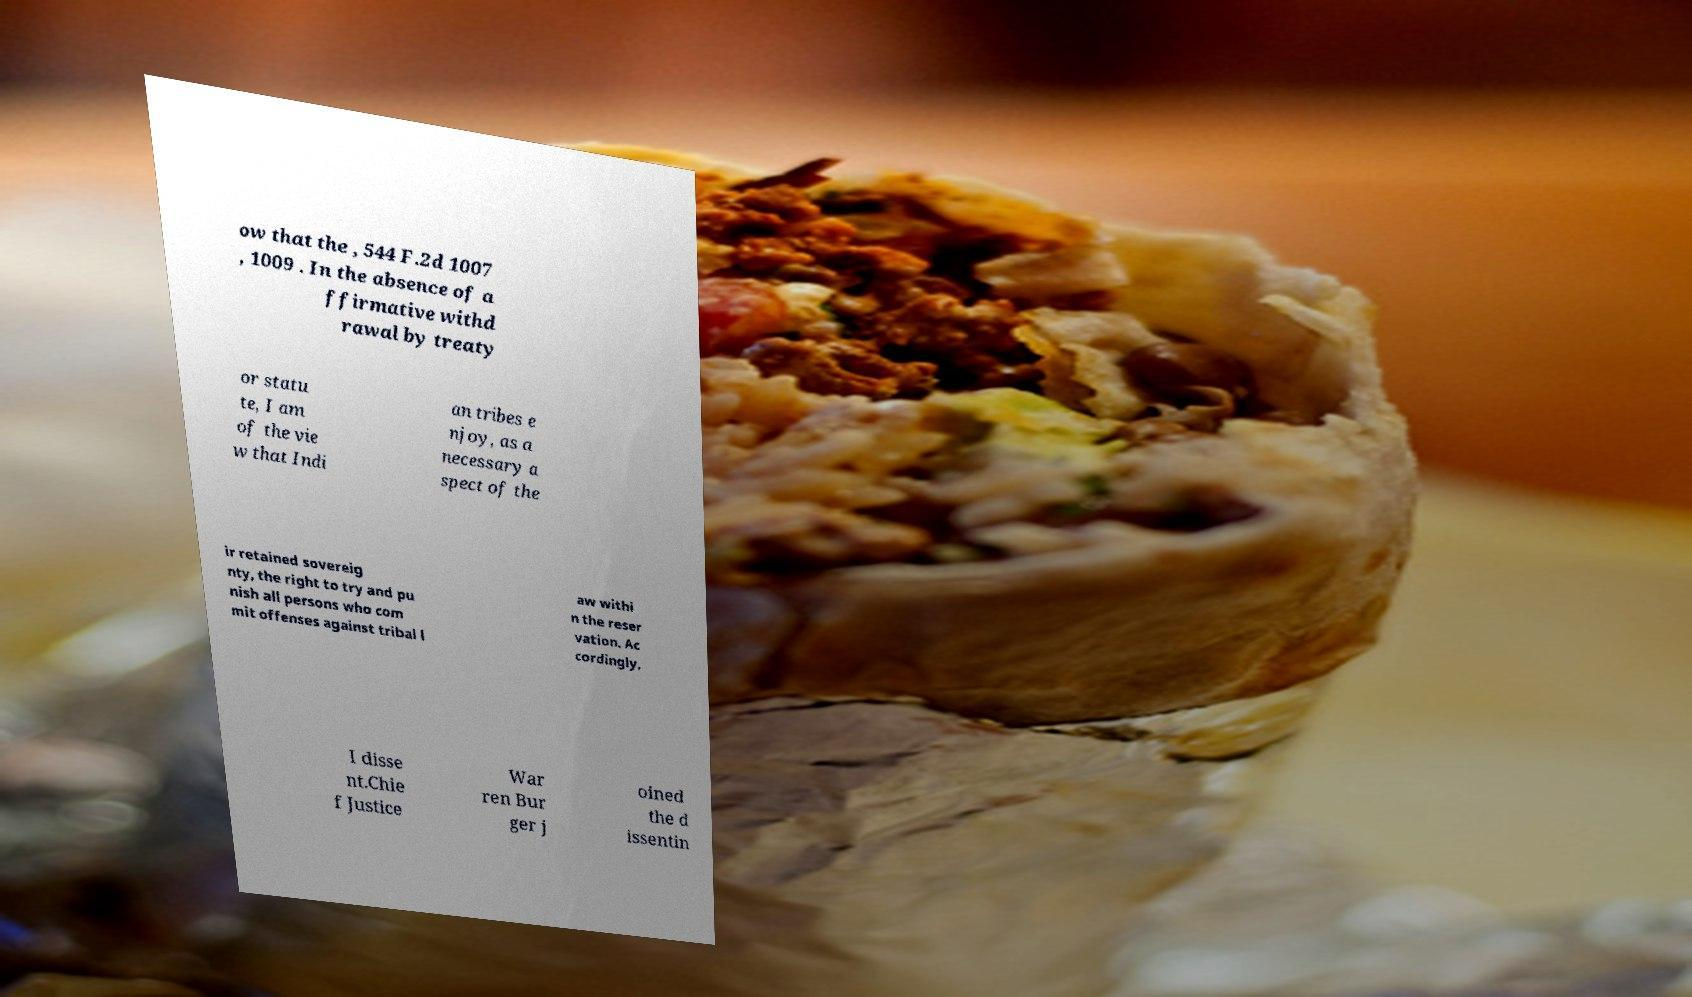I need the written content from this picture converted into text. Can you do that? ow that the , 544 F.2d 1007 , 1009 . In the absence of a ffirmative withd rawal by treaty or statu te, I am of the vie w that Indi an tribes e njoy, as a necessary a spect of the ir retained sovereig nty, the right to try and pu nish all persons who com mit offenses against tribal l aw withi n the reser vation. Ac cordingly, I disse nt.Chie f Justice War ren Bur ger j oined the d issentin 